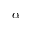<formula> <loc_0><loc_0><loc_500><loc_500>\alpha</formula> 